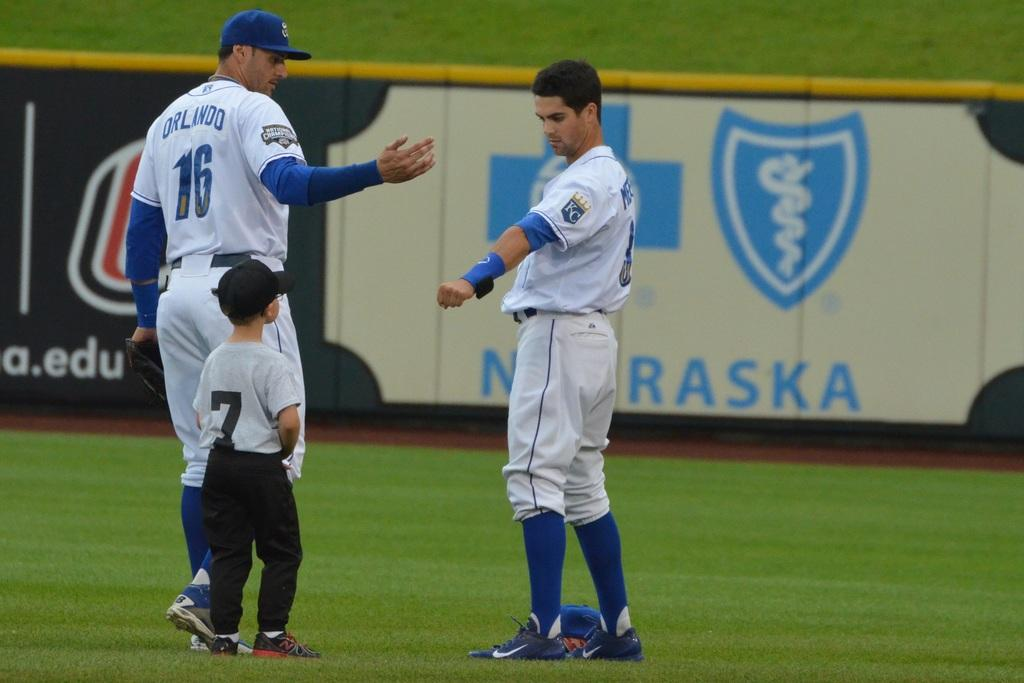Provide a one-sentence caption for the provided image. A child wearing jersey number 7 approached the two Kansas City Royals players near the Blue Cross Blue Shield Nebraska advertisement. 